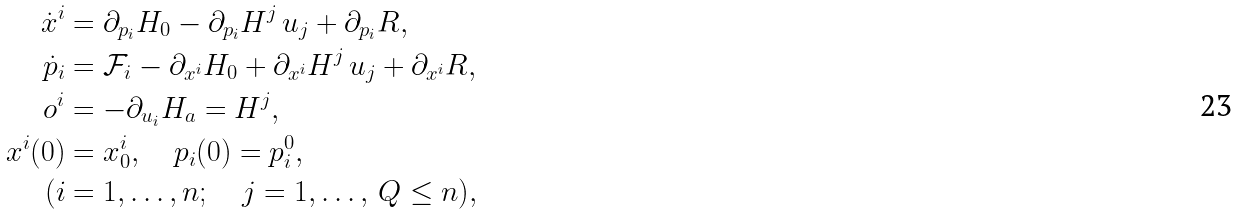<formula> <loc_0><loc_0><loc_500><loc_500>\dot { x } ^ { i } & = \partial _ { p _ { i } } H _ { 0 } - \partial _ { p _ { i } } H ^ { j } \, u _ { j } + \partial _ { p _ { i } } R , \\ \dot { p } _ { i } & = \mathcal { F } _ { i } - \partial _ { x ^ { i } } H _ { 0 } + \partial _ { x ^ { i } } H ^ { j } \, u _ { j } + \partial _ { x ^ { i } } R , \\ o ^ { i } & = - \partial _ { u _ { i } } H _ { a } = H ^ { j } , \\ x ^ { i } ( 0 ) & = x _ { 0 } ^ { i } , \quad p _ { i } ( 0 ) = p _ { i } ^ { 0 } , \\ ( i & = 1 , \dots , n ; \quad j = 1 , \dots , \, Q \leq n ) ,</formula> 